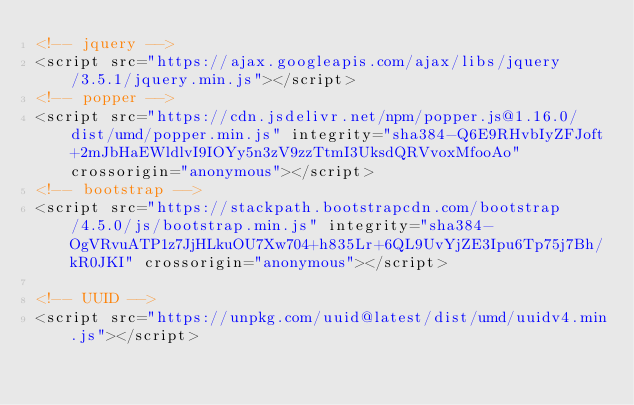Convert code to text. <code><loc_0><loc_0><loc_500><loc_500><_HTML_><!-- jquery -->
<script src="https://ajax.googleapis.com/ajax/libs/jquery/3.5.1/jquery.min.js"></script>
<!-- popper -->
<script src="https://cdn.jsdelivr.net/npm/popper.js@1.16.0/dist/umd/popper.min.js" integrity="sha384-Q6E9RHvbIyZFJoft+2mJbHaEWldlvI9IOYy5n3zV9zzTtmI3UksdQRVvoxMfooAo" crossorigin="anonymous"></script>
<!-- bootstrap -->
<script src="https://stackpath.bootstrapcdn.com/bootstrap/4.5.0/js/bootstrap.min.js" integrity="sha384-OgVRvuATP1z7JjHLkuOU7Xw704+h835Lr+6QL9UvYjZE3Ipu6Tp75j7Bh/kR0JKI" crossorigin="anonymous"></script>

<!-- UUID -->
<script src="https://unpkg.com/uuid@latest/dist/umd/uuidv4.min.js"></script></code> 